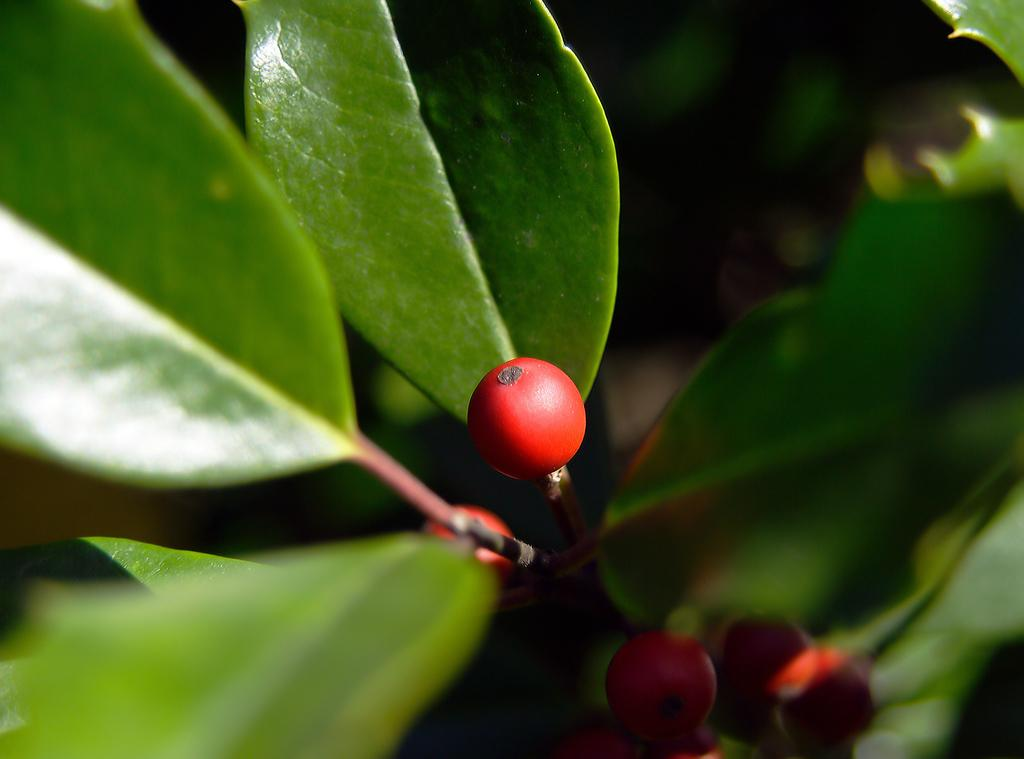What type of fruits can be seen in the image? There are small red color fruits in the image. Where are the fruits located? The fruits are on a plant. Can you describe the background of the plant? The background of the plant is blurred. How many sheep are visible in the image? There are no sheep present in the image. Is there a giraffe standing next to the plant in the image? There is no giraffe present in the image. 